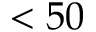Convert formula to latex. <formula><loc_0><loc_0><loc_500><loc_500>< 5 0</formula> 